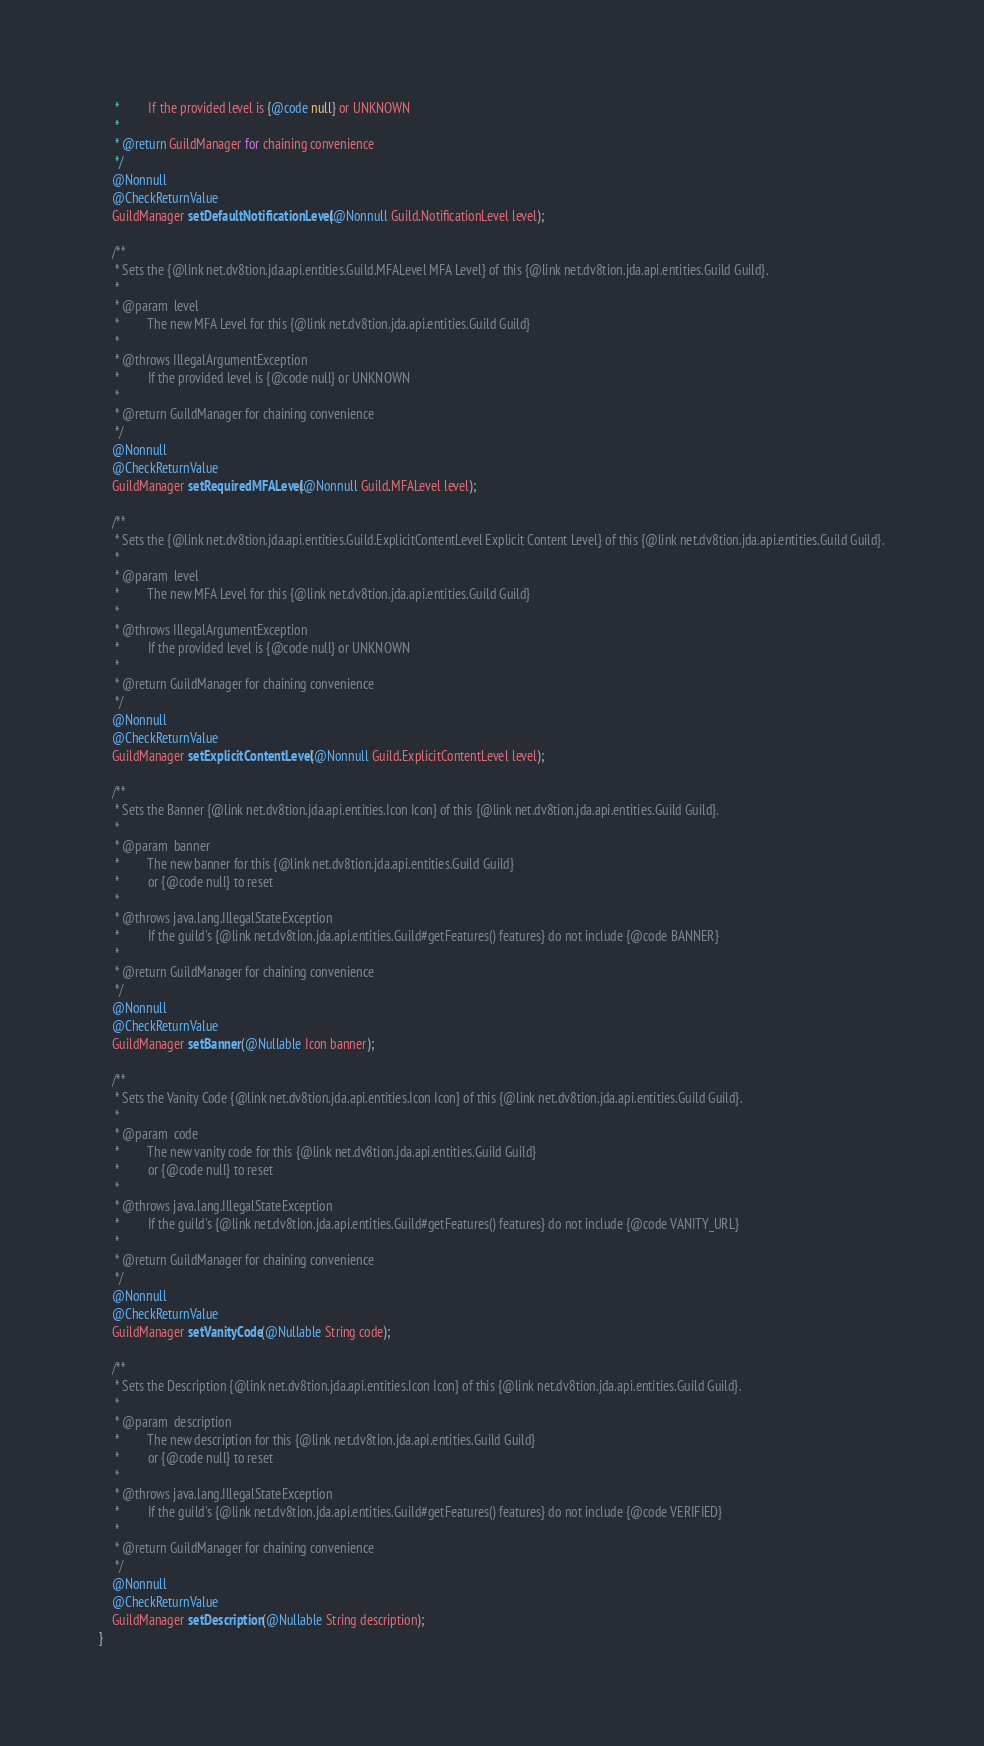Convert code to text. <code><loc_0><loc_0><loc_500><loc_500><_Java_>     *         If the provided level is {@code null} or UNKNOWN
     *
     * @return GuildManager for chaining convenience
     */
    @Nonnull
    @CheckReturnValue
    GuildManager setDefaultNotificationLevel(@Nonnull Guild.NotificationLevel level);

    /**
     * Sets the {@link net.dv8tion.jda.api.entities.Guild.MFALevel MFA Level} of this {@link net.dv8tion.jda.api.entities.Guild Guild}.
     *
     * @param  level
     *         The new MFA Level for this {@link net.dv8tion.jda.api.entities.Guild Guild}
     *
     * @throws IllegalArgumentException
     *         If the provided level is {@code null} or UNKNOWN
     *
     * @return GuildManager for chaining convenience
     */
    @Nonnull
    @CheckReturnValue
    GuildManager setRequiredMFALevel(@Nonnull Guild.MFALevel level);

    /**
     * Sets the {@link net.dv8tion.jda.api.entities.Guild.ExplicitContentLevel Explicit Content Level} of this {@link net.dv8tion.jda.api.entities.Guild Guild}.
     *
     * @param  level
     *         The new MFA Level for this {@link net.dv8tion.jda.api.entities.Guild Guild}
     *
     * @throws IllegalArgumentException
     *         If the provided level is {@code null} or UNKNOWN
     *
     * @return GuildManager for chaining convenience
     */
    @Nonnull
    @CheckReturnValue
    GuildManager setExplicitContentLevel(@Nonnull Guild.ExplicitContentLevel level);

    /**
     * Sets the Banner {@link net.dv8tion.jda.api.entities.Icon Icon} of this {@link net.dv8tion.jda.api.entities.Guild Guild}.
     *
     * @param  banner
     *         The new banner for this {@link net.dv8tion.jda.api.entities.Guild Guild}
     *         or {@code null} to reset
     *
     * @throws java.lang.IllegalStateException
     *         If the guild's {@link net.dv8tion.jda.api.entities.Guild#getFeatures() features} do not include {@code BANNER}
     *
     * @return GuildManager for chaining convenience
     */
    @Nonnull
    @CheckReturnValue
    GuildManager setBanner(@Nullable Icon banner);

    /**
     * Sets the Vanity Code {@link net.dv8tion.jda.api.entities.Icon Icon} of this {@link net.dv8tion.jda.api.entities.Guild Guild}.
     *
     * @param  code
     *         The new vanity code for this {@link net.dv8tion.jda.api.entities.Guild Guild}
     *         or {@code null} to reset
     *
     * @throws java.lang.IllegalStateException
     *         If the guild's {@link net.dv8tion.jda.api.entities.Guild#getFeatures() features} do not include {@code VANITY_URL}
     *
     * @return GuildManager for chaining convenience
     */
    @Nonnull
    @CheckReturnValue
    GuildManager setVanityCode(@Nullable String code);

    /**
     * Sets the Description {@link net.dv8tion.jda.api.entities.Icon Icon} of this {@link net.dv8tion.jda.api.entities.Guild Guild}.
     *
     * @param  description
     *         The new description for this {@link net.dv8tion.jda.api.entities.Guild Guild}
     *         or {@code null} to reset
     *
     * @throws java.lang.IllegalStateException
     *         If the guild's {@link net.dv8tion.jda.api.entities.Guild#getFeatures() features} do not include {@code VERIFIED}
     *
     * @return GuildManager for chaining convenience
     */
    @Nonnull
    @CheckReturnValue
    GuildManager setDescription(@Nullable String description);
}
</code> 